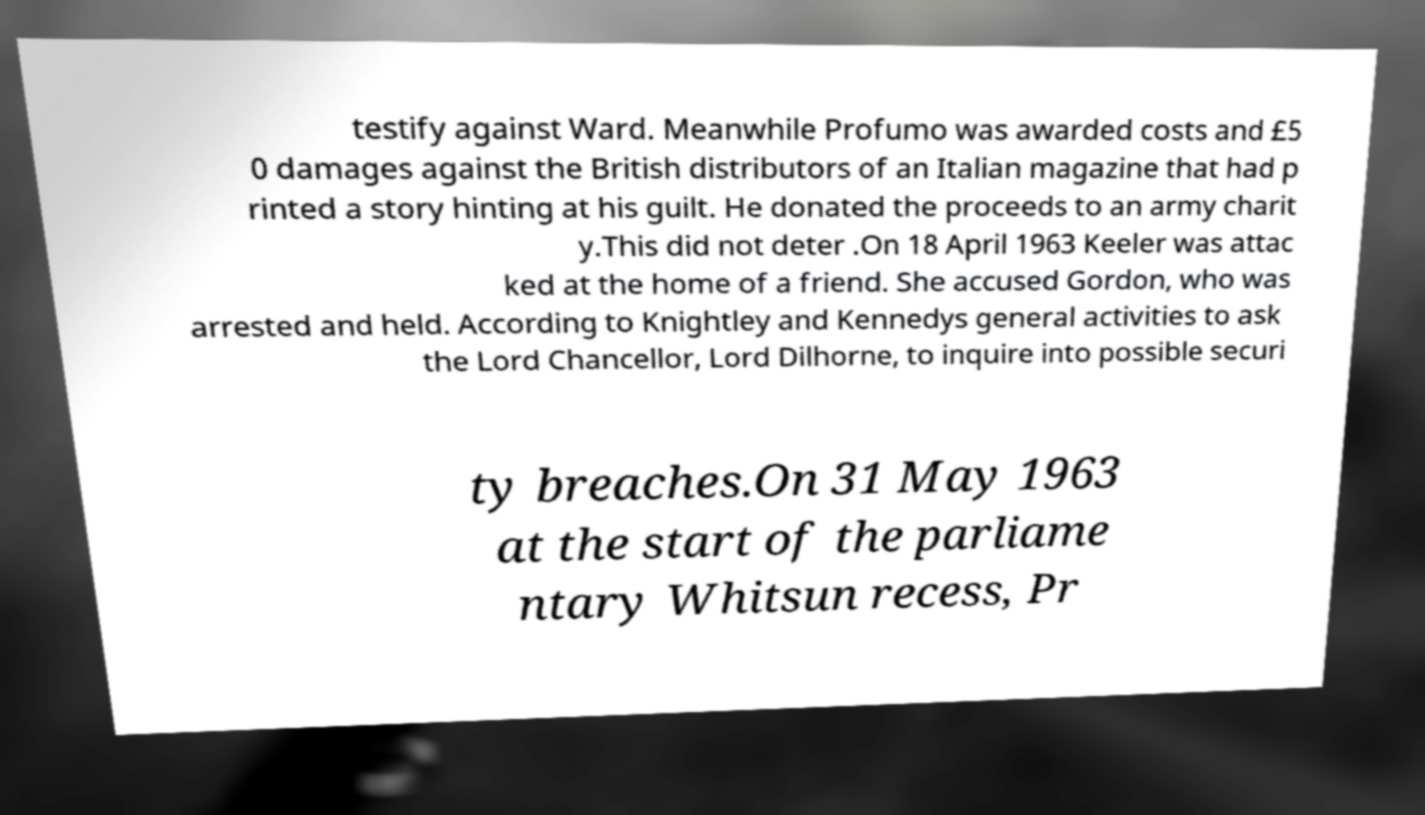There's text embedded in this image that I need extracted. Can you transcribe it verbatim? testify against Ward. Meanwhile Profumo was awarded costs and £5 0 damages against the British distributors of an Italian magazine that had p rinted a story hinting at his guilt. He donated the proceeds to an army charit y.This did not deter .On 18 April 1963 Keeler was attac ked at the home of a friend. She accused Gordon, who was arrested and held. According to Knightley and Kennedys general activities to ask the Lord Chancellor, Lord Dilhorne, to inquire into possible securi ty breaches.On 31 May 1963 at the start of the parliame ntary Whitsun recess, Pr 